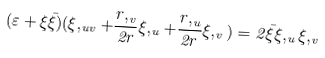Convert formula to latex. <formula><loc_0><loc_0><loc_500><loc_500>( \varepsilon + \xi \bar { \xi } ) ( \xi , _ { u v } + \frac { r , _ { v } } { 2 r } \xi , _ { u } + \frac { r , _ { u } } { 2 r } \xi , _ { v } ) = 2 \bar { \xi } \xi , _ { u } \xi , _ { v }</formula> 